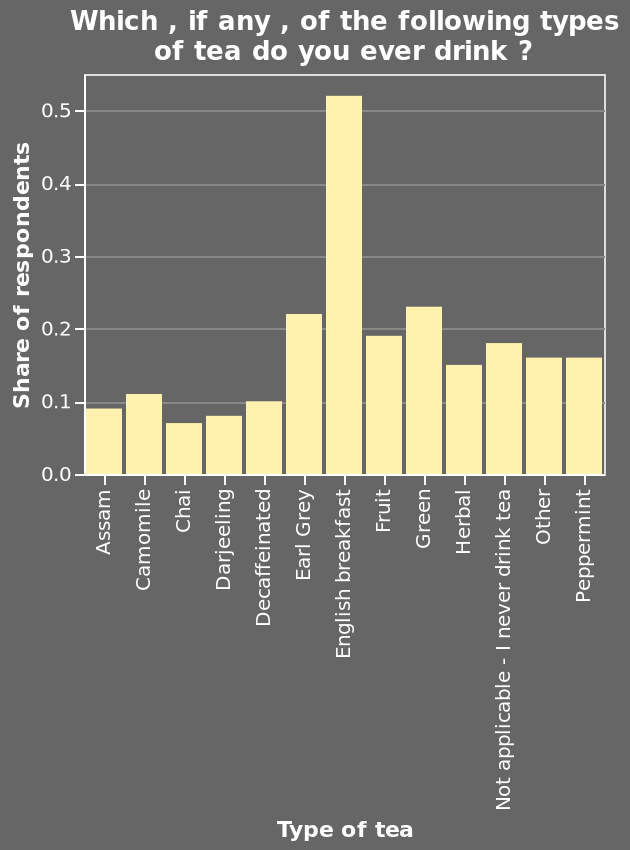<image>
What is represented on the x-axis of the bar diagram?  The x-axis of the bar diagram represents the types of tea. please describe the details of the chart Here a is a bar diagram titled Which , if any , of the following types of tea do you ever drink ?. The y-axis shows Share of respondents. Type of tea is shown on the x-axis. What is the highest value English breakfast tea by a factor of more than double?  English breakfast tea. 